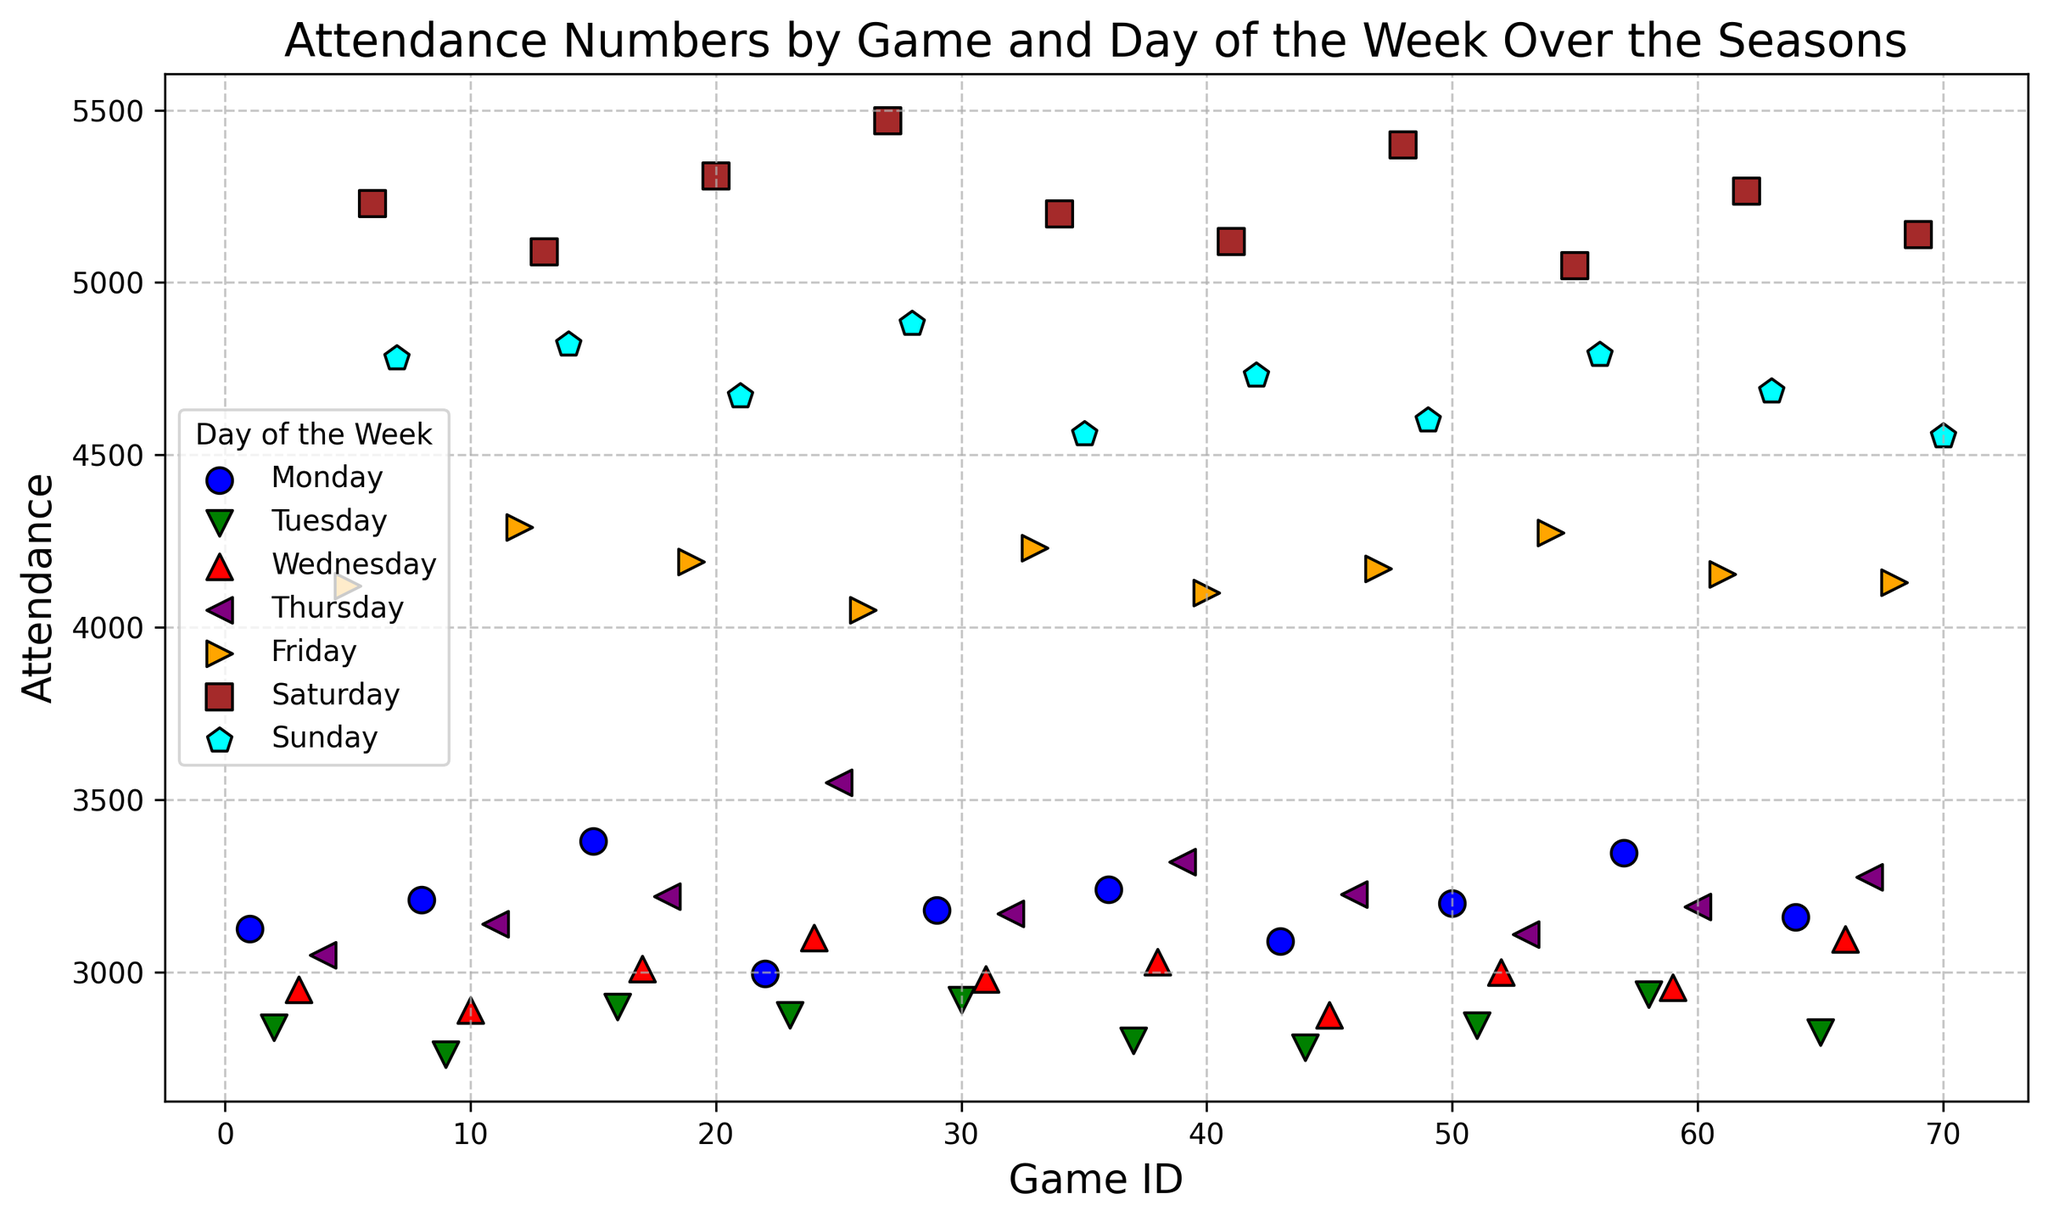What's the average attendance for Saturday games? To find the average attendance for Saturday games, look at the data points for Saturday and add them up: (5230 + 5090 + 5310 + 5470 + 5200 + 5120 + 5400 + 5050 + 5265 + 5140). Then divide by the number of Saturday games (10). The sum is 52275, and dividing this by 10 gives the average.
Answer: 5227.5 How does the attendance on Mondays compare to Fridays? For comparison, note the trend or individual data points. It shows that Monday games have consistently lower attendance numbers compared to Friday games. For example, the average Monday attendance is around 3168, while the average Friday attendance is about 4213.
Answer: Monday attendance is lower than Friday attendance Which day of the week has the highest attendance and what is that number? Looking at the scatter plot, identify the highest attendance data point and note the corresponding day of the week. The highest attendance is on a Saturday with an attendance of 5470.
Answer: Saturday, 5470 What is the range of attendance for Sunday games? Identify the lowest and highest attendance for Sunday games. The lowest is 4555 and the highest is 4880. Subtract the lowest from the highest to find the range: 4880 - 4555 = 325.
Answer: 325 Is there a noticeable trend in attendance as the week progresses from Monday to Sunday? Observing the scatter plot, notice that attendance generally increases from Monday to Sunday, peaking on weekends (Saturday and Sunday). The weekdays show a lower attendance compared to weekends.
Answer: Yes, attendance increases towards the weekend What is the median attendance for all games combined? To find the median, list all attendance values in ascending order and find the middle value. With 70 games, the median will be the average of the 35th and 36th values. The 35th and 36th values are 3190 and 3200, respectively. So, the median is (3190 + 3200)/2 = 3195.
Answer: 3195 What is the average attendance for weekdays (Monday to Friday) compared to weekends (Saturday and Sunday)? Calculate the average attendance for Monday to Friday and compare it to the average for Saturday and Sunday. Summing the weekday attendances and dividing by the total number of weekday games (50), and doing the same for weekend attendances (20). For weekdays: (50645/50 = 3160.9). For weekends: (102700/20 = 5135).
Answer: Weekday: 3160.9; Weekend: 5135 